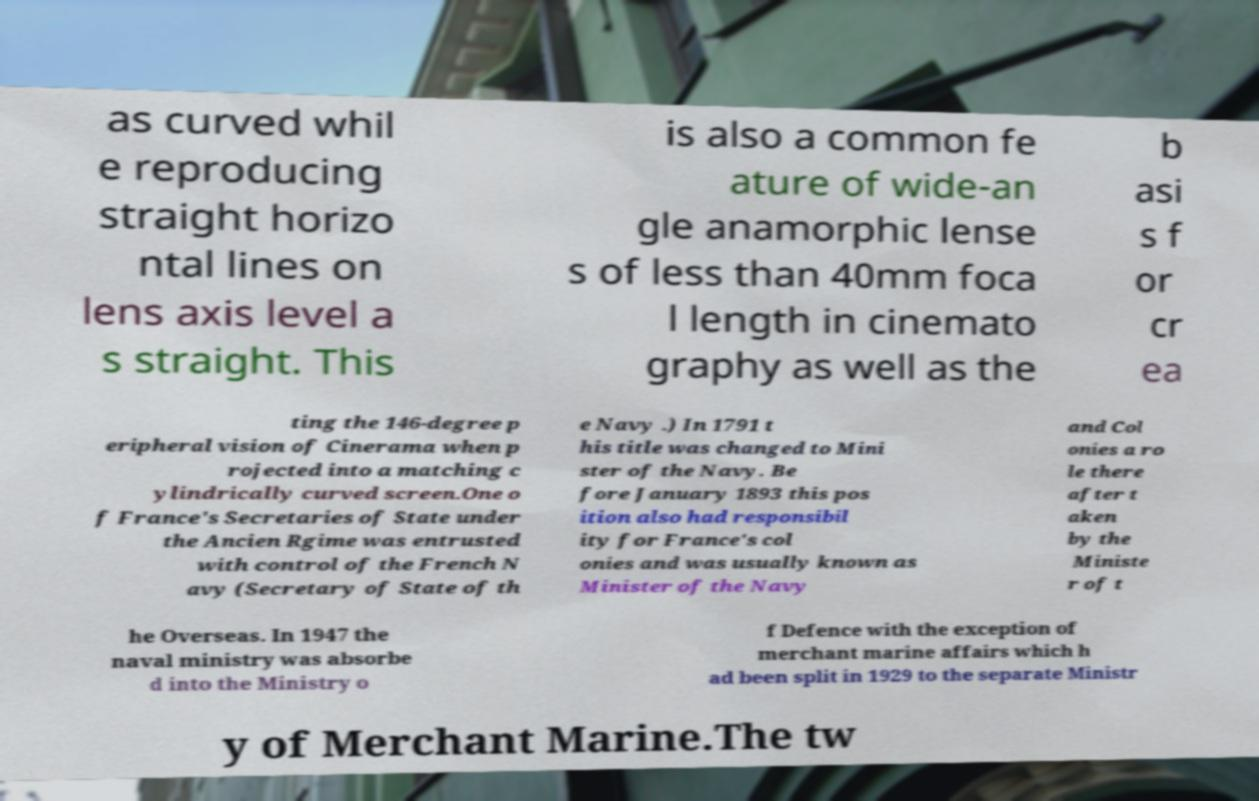Can you read and provide the text displayed in the image?This photo seems to have some interesting text. Can you extract and type it out for me? as curved whil e reproducing straight horizo ntal lines on lens axis level a s straight. This is also a common fe ature of wide-an gle anamorphic lense s of less than 40mm foca l length in cinemato graphy as well as the b asi s f or cr ea ting the 146-degree p eripheral vision of Cinerama when p rojected into a matching c ylindrically curved screen.One o f France's Secretaries of State under the Ancien Rgime was entrusted with control of the French N avy (Secretary of State of th e Navy .) In 1791 t his title was changed to Mini ster of the Navy. Be fore January 1893 this pos ition also had responsibil ity for France's col onies and was usually known as Minister of the Navy and Col onies a ro le there after t aken by the Ministe r of t he Overseas. In 1947 the naval ministry was absorbe d into the Ministry o f Defence with the exception of merchant marine affairs which h ad been split in 1929 to the separate Ministr y of Merchant Marine.The tw 